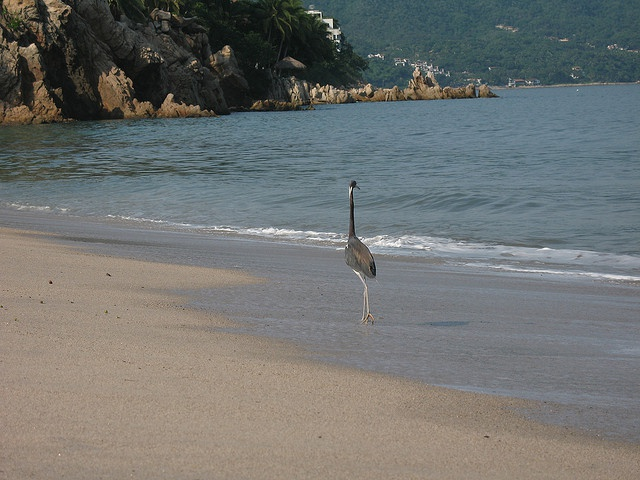Describe the objects in this image and their specific colors. I can see a bird in black, gray, and darkgray tones in this image. 